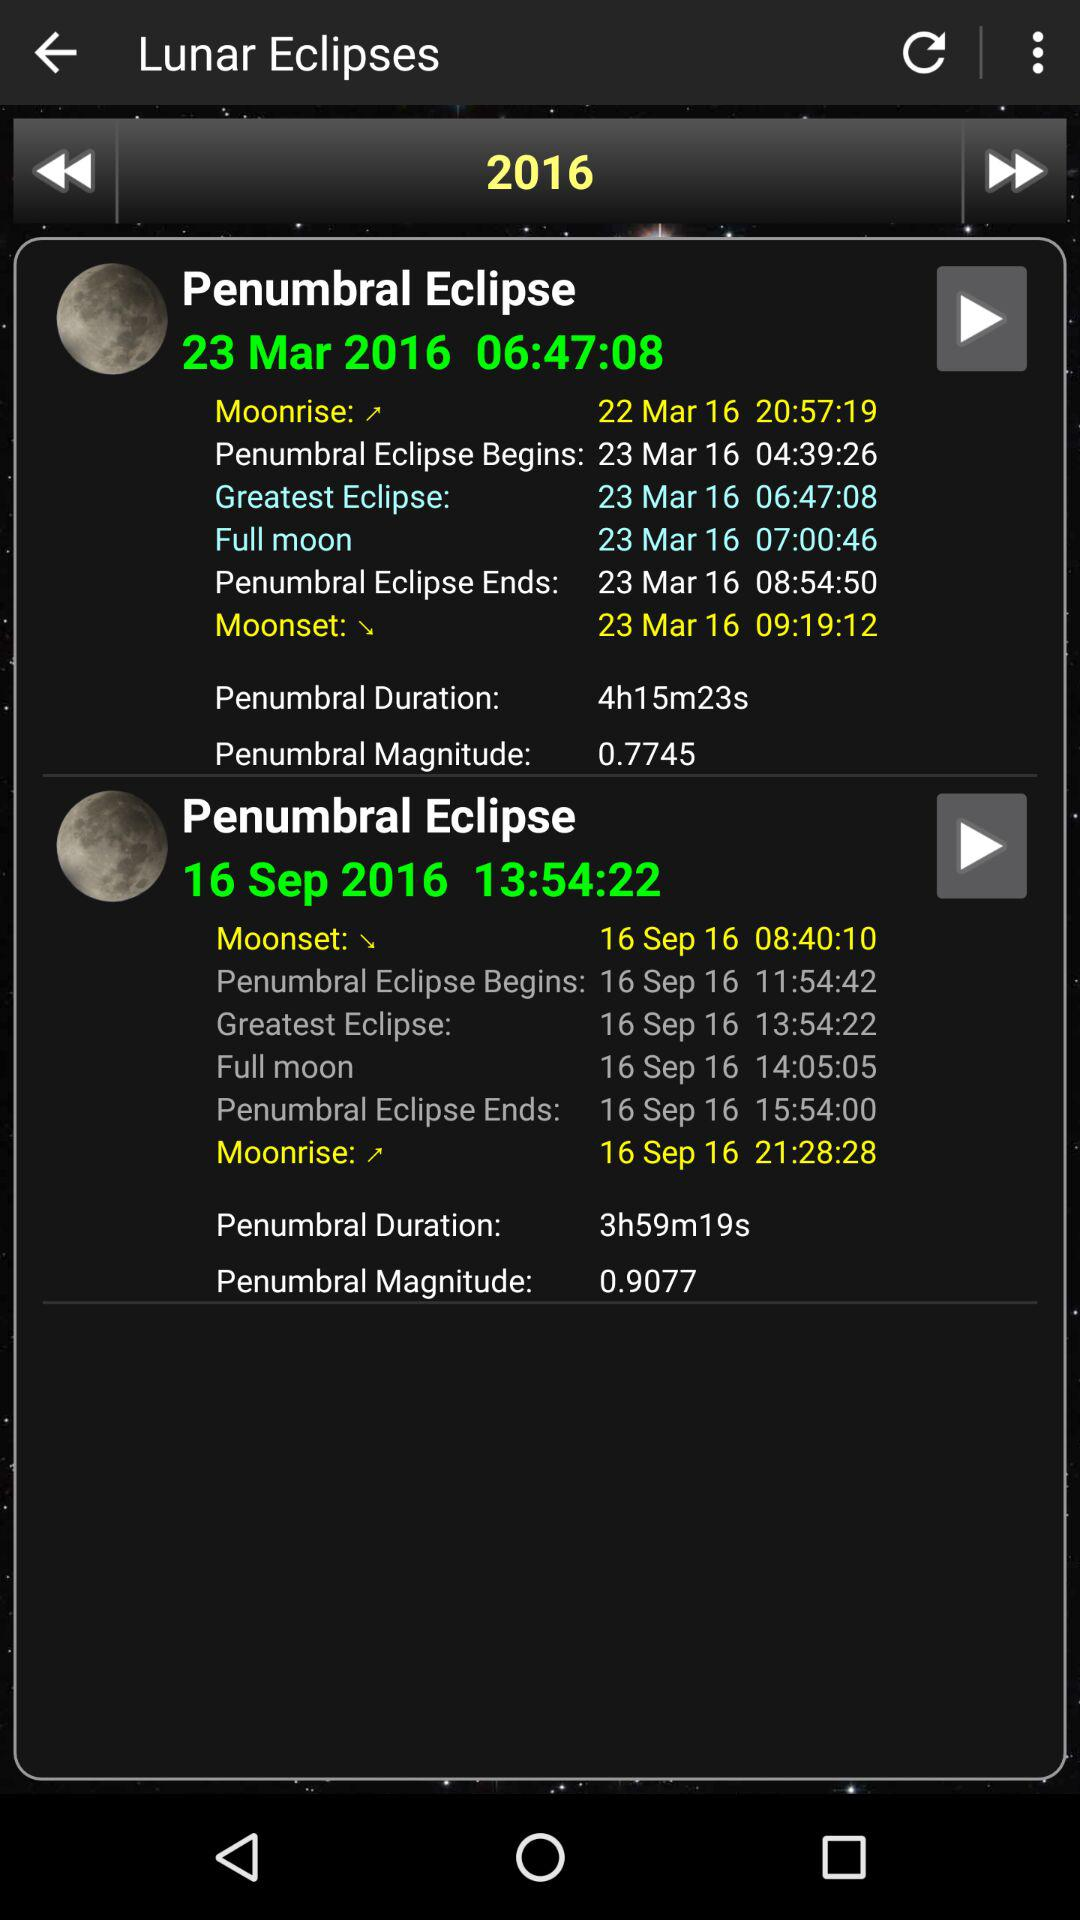What is the timing for the full moon on the 16th of September eclipse? The timing for the full moon on the 16th of September eclipse is 14:05:05. 